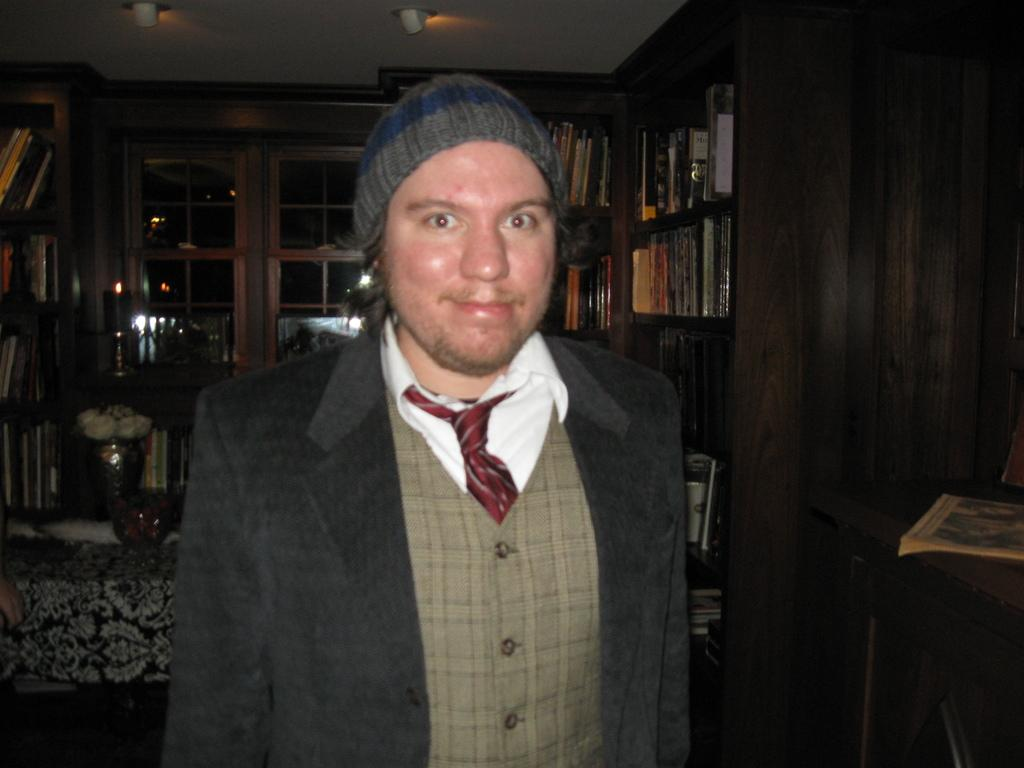What is the man in the image doing? The man is standing and smiling in the image. What can be seen in the background of the image? There are lights, a window, a flower vase, a carpet, and books in racks in the background of the image. What type of yarn is being used to create the design on the carpet in the image? There is no yarn or design on the carpet in the image; it is a solid color. How many bushes are visible outside the window in the image? There are no bushes visible outside the window in the image; only the window and the lights in the background can be seen. 